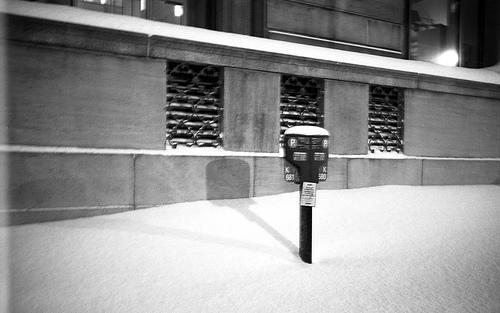How many lights are visible?
Give a very brief answer. 4. How many grates are on the building's side?
Give a very brief answer. 3. How many grates are behind a parking meter?
Give a very brief answer. 1. 